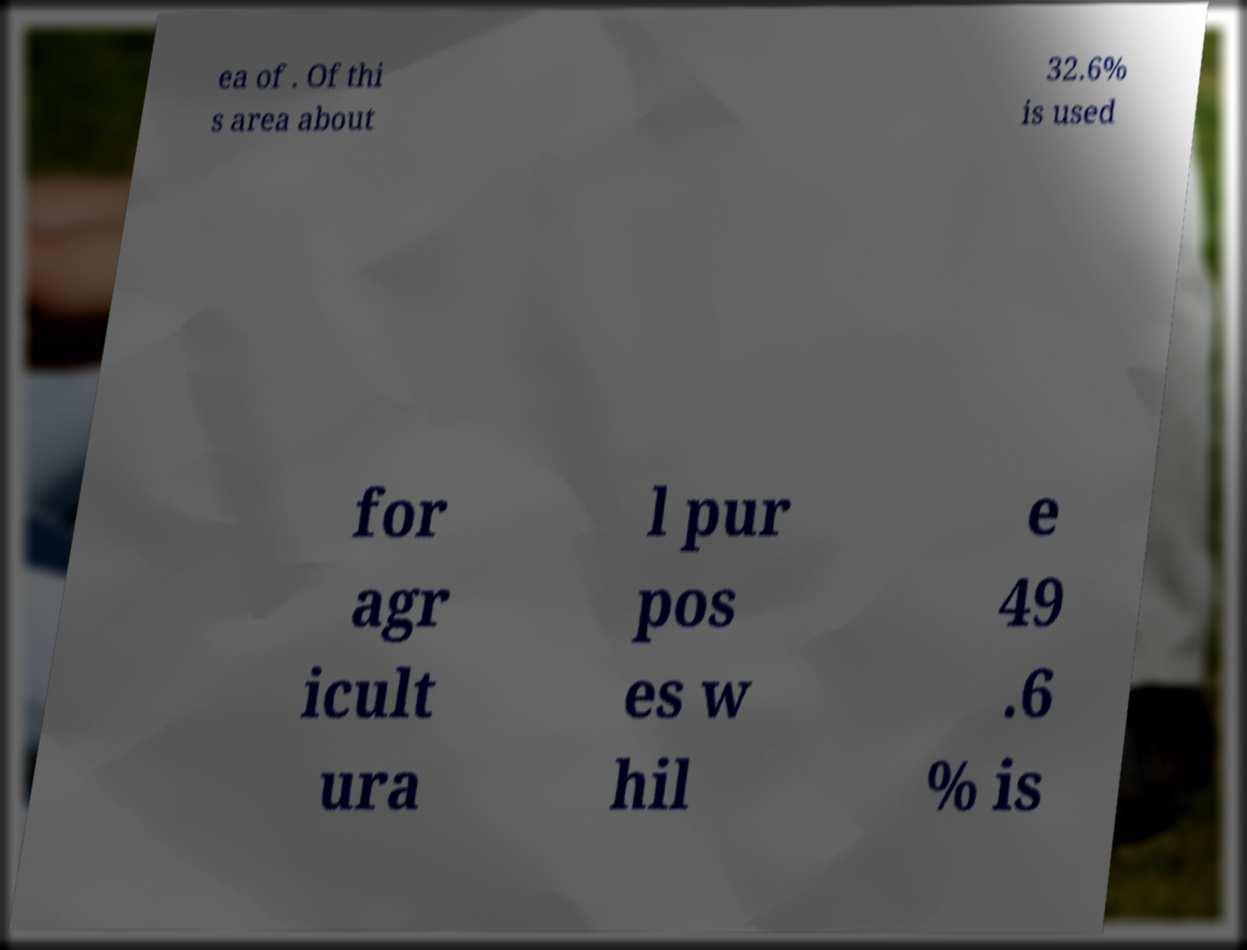Can you accurately transcribe the text from the provided image for me? ea of . Of thi s area about 32.6% is used for agr icult ura l pur pos es w hil e 49 .6 % is 